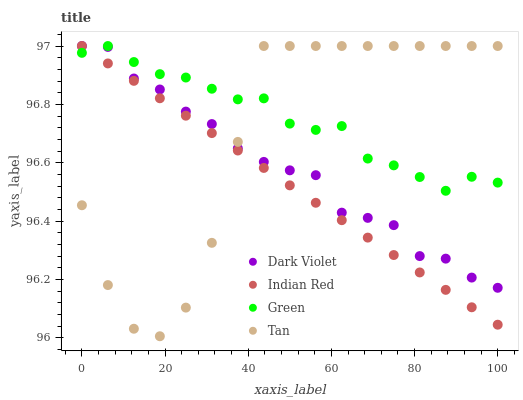Does Indian Red have the minimum area under the curve?
Answer yes or no. Yes. Does Green have the maximum area under the curve?
Answer yes or no. Yes. Does Green have the minimum area under the curve?
Answer yes or no. No. Does Indian Red have the maximum area under the curve?
Answer yes or no. No. Is Indian Red the smoothest?
Answer yes or no. Yes. Is Tan the roughest?
Answer yes or no. Yes. Is Green the smoothest?
Answer yes or no. No. Is Green the roughest?
Answer yes or no. No. Does Tan have the lowest value?
Answer yes or no. Yes. Does Indian Red have the lowest value?
Answer yes or no. No. Does Dark Violet have the highest value?
Answer yes or no. Yes. Does Tan intersect Dark Violet?
Answer yes or no. Yes. Is Tan less than Dark Violet?
Answer yes or no. No. Is Tan greater than Dark Violet?
Answer yes or no. No. 